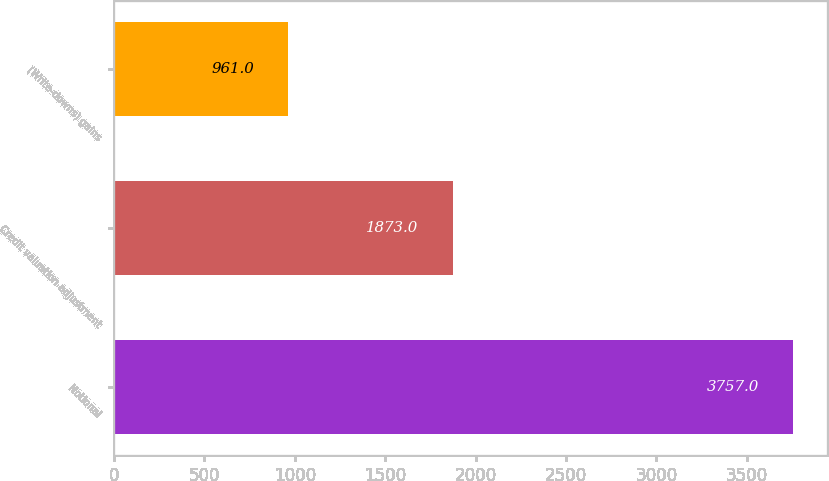<chart> <loc_0><loc_0><loc_500><loc_500><bar_chart><fcel>Notional<fcel>Credit valuation adjustment<fcel>(Write-downs) gains<nl><fcel>3757<fcel>1873<fcel>961<nl></chart> 